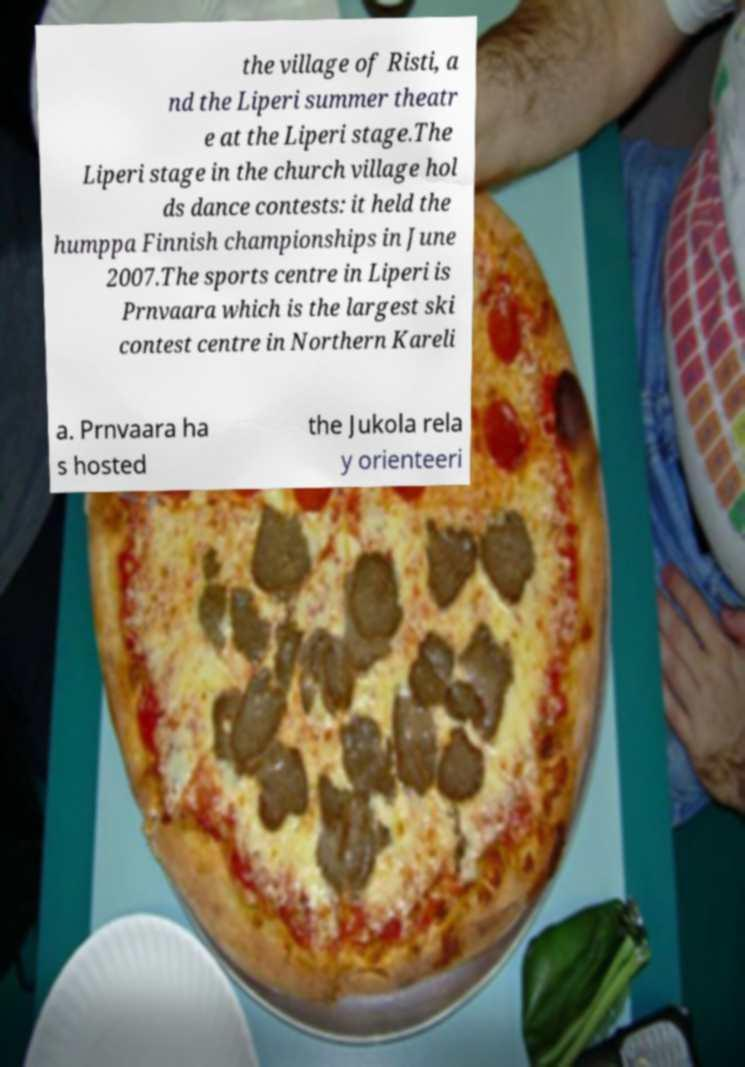Please read and relay the text visible in this image. What does it say? the village of Risti, a nd the Liperi summer theatr e at the Liperi stage.The Liperi stage in the church village hol ds dance contests: it held the humppa Finnish championships in June 2007.The sports centre in Liperi is Prnvaara which is the largest ski contest centre in Northern Kareli a. Prnvaara ha s hosted the Jukola rela y orienteeri 